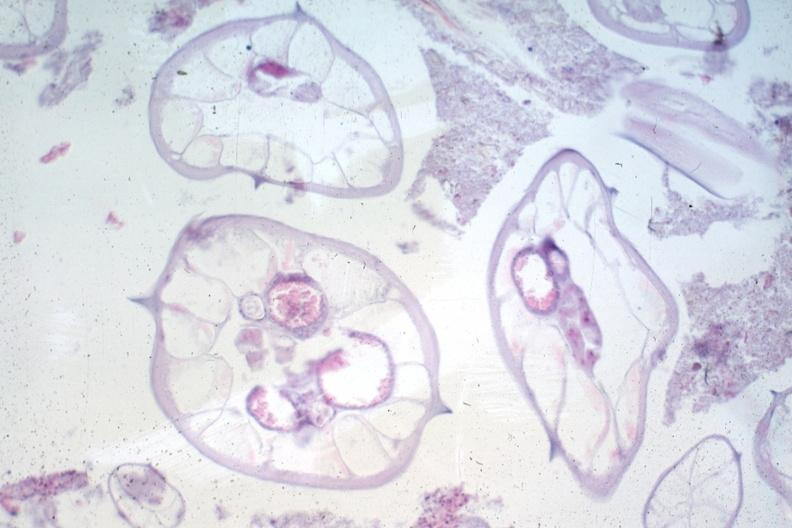does this image show worms no appendix structures?
Answer the question using a single word or phrase. Yes 